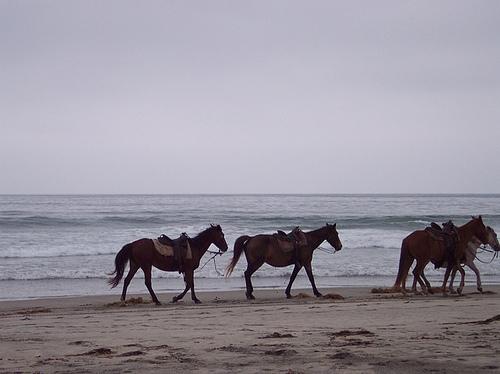Is the water calm?
Keep it brief. Yes. Are people riding these horses?
Answer briefly. No. How many horses are in the photo?
Short answer required. 4. How many horses are in this picture?
Answer briefly. 4. Do all of the horses have saddles on?
Short answer required. Yes. What color is the horse leading the group?
Short answer required. White. 